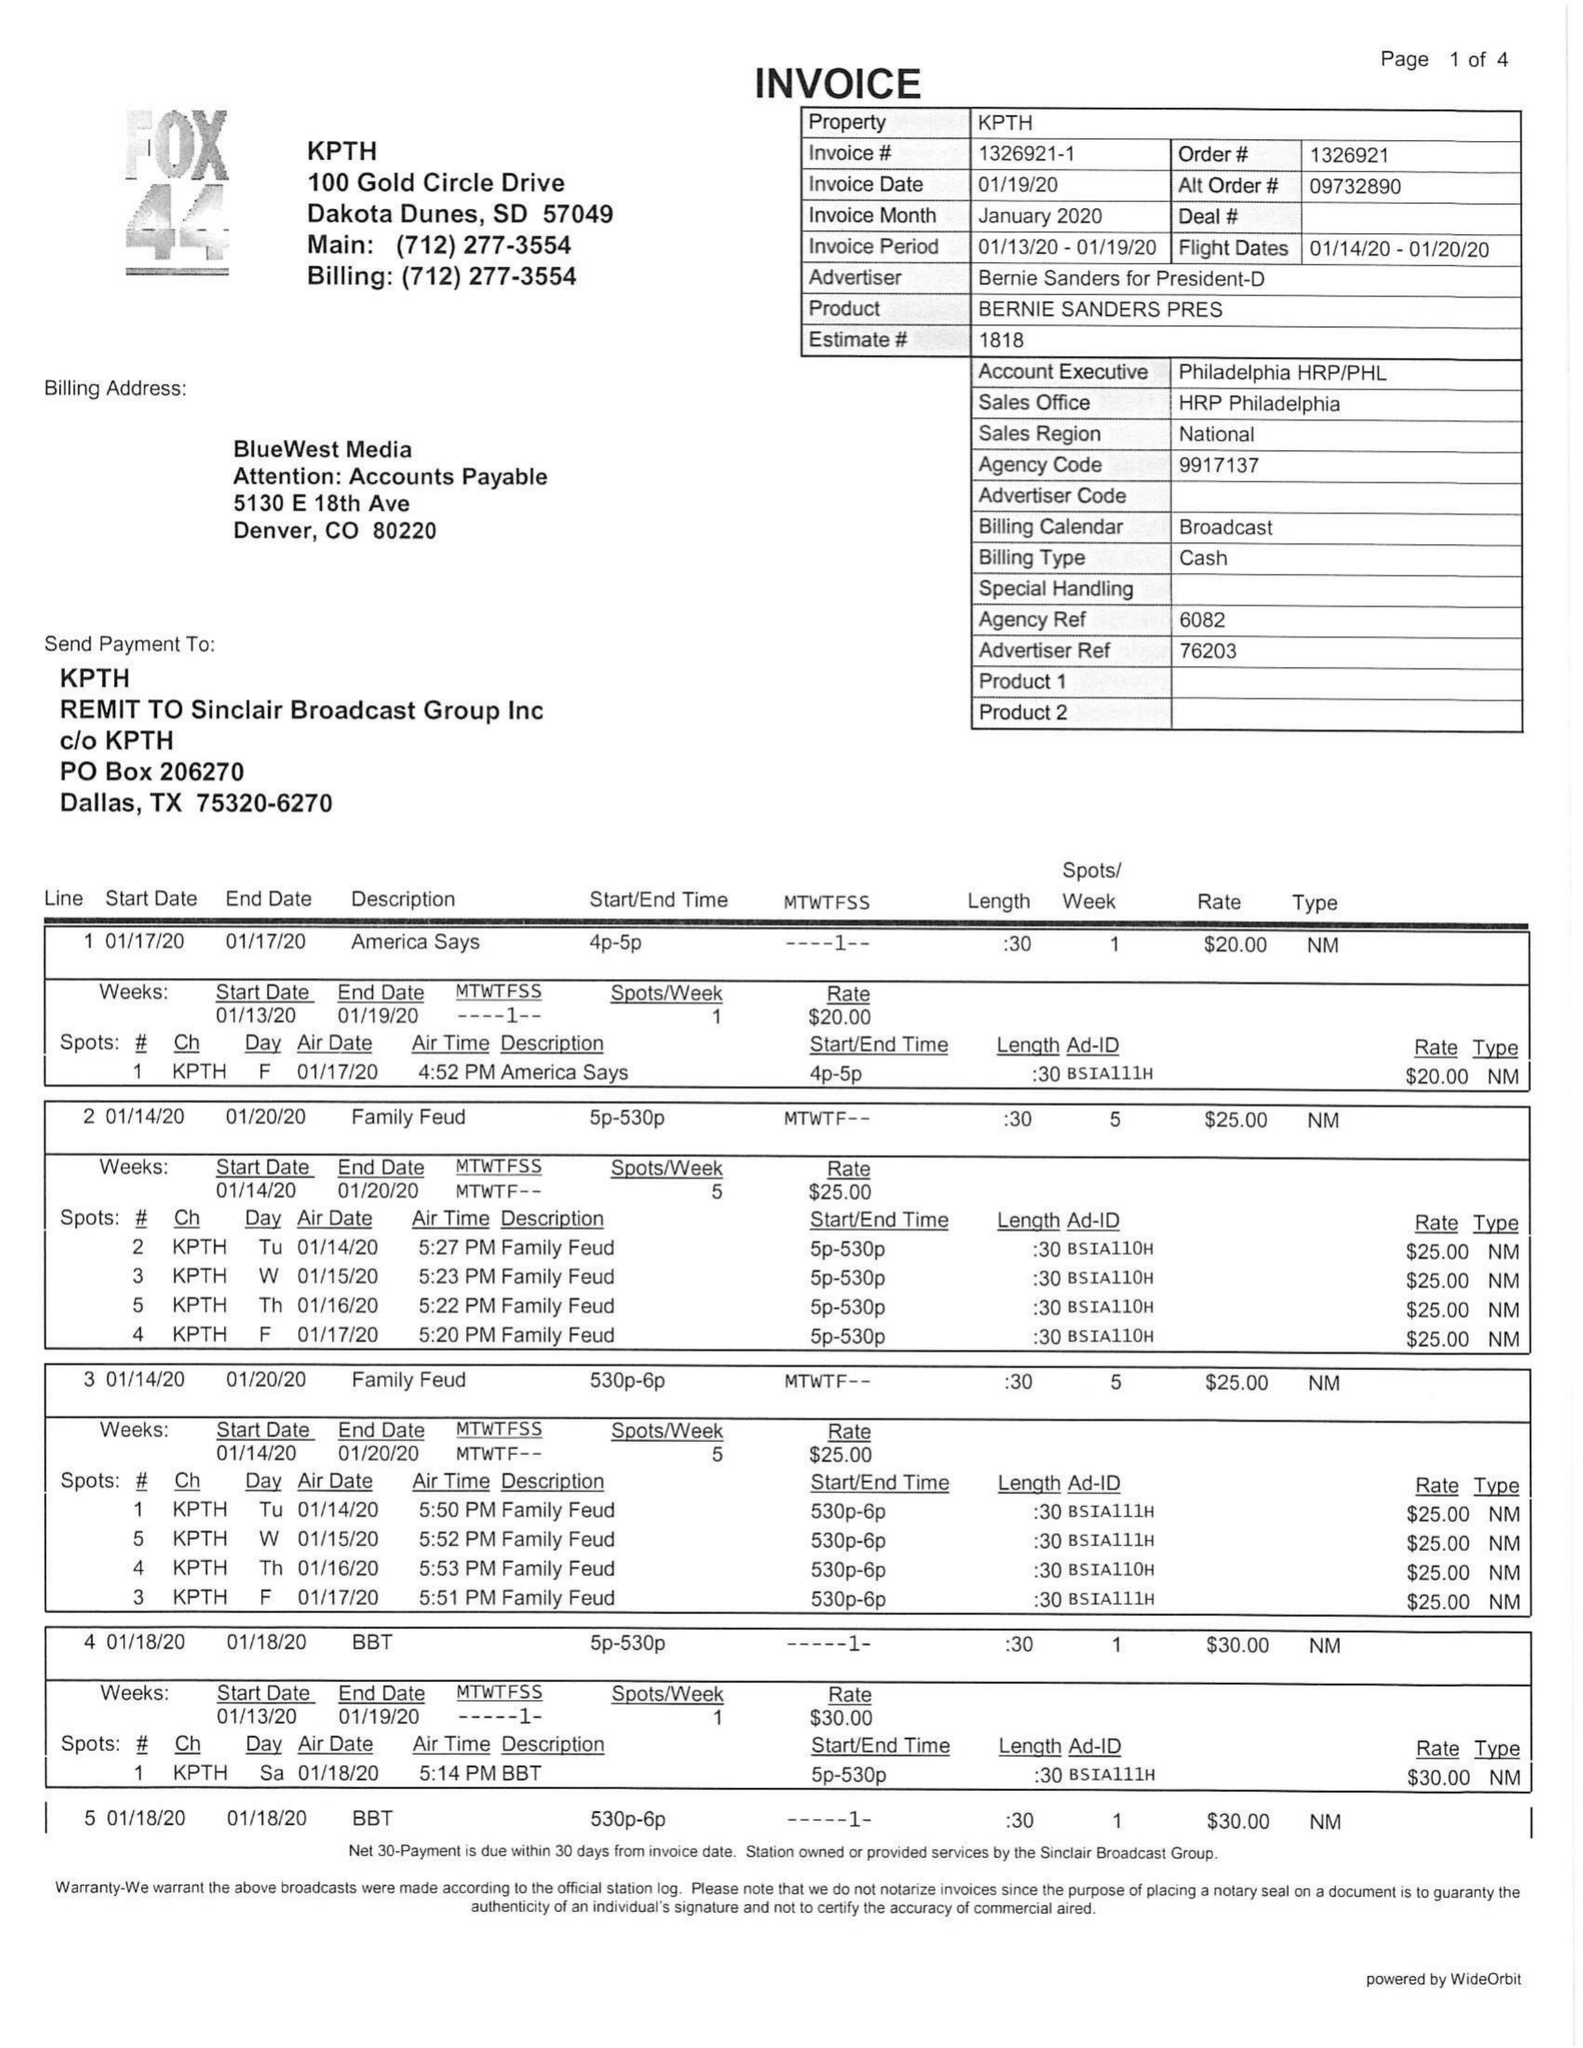What is the value for the gross_amount?
Answer the question using a single word or phrase. 2364.00 